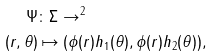Convert formula to latex. <formula><loc_0><loc_0><loc_500><loc_500>\Psi & \colon \Sigma \to \real ^ { 2 } \\ ( r , \theta ) & \mapsto ( \phi ( r ) h _ { 1 } ( \theta ) , \phi ( r ) h _ { 2 } ( \theta ) ) ,</formula> 